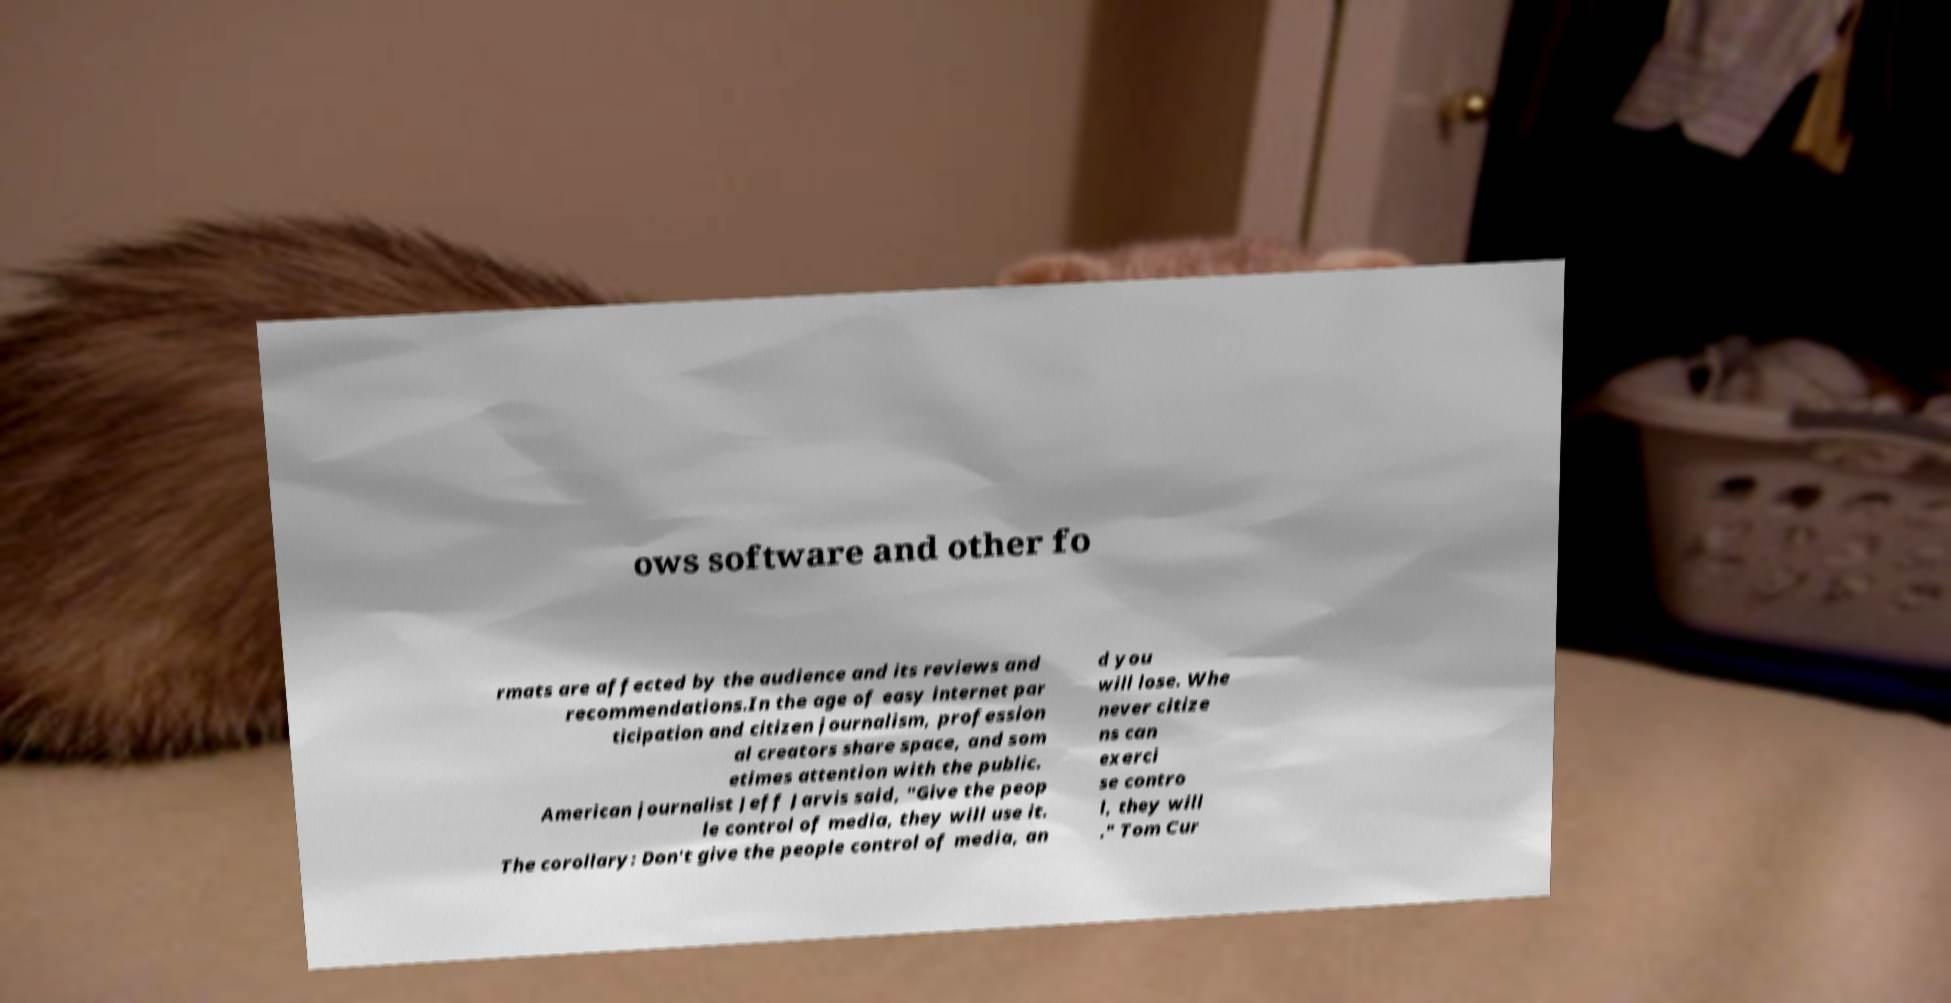Can you read and provide the text displayed in the image?This photo seems to have some interesting text. Can you extract and type it out for me? ows software and other fo rmats are affected by the audience and its reviews and recommendations.In the age of easy internet par ticipation and citizen journalism, profession al creators share space, and som etimes attention with the public. American journalist Jeff Jarvis said, "Give the peop le control of media, they will use it. The corollary: Don't give the people control of media, an d you will lose. Whe never citize ns can exerci se contro l, they will ." Tom Cur 